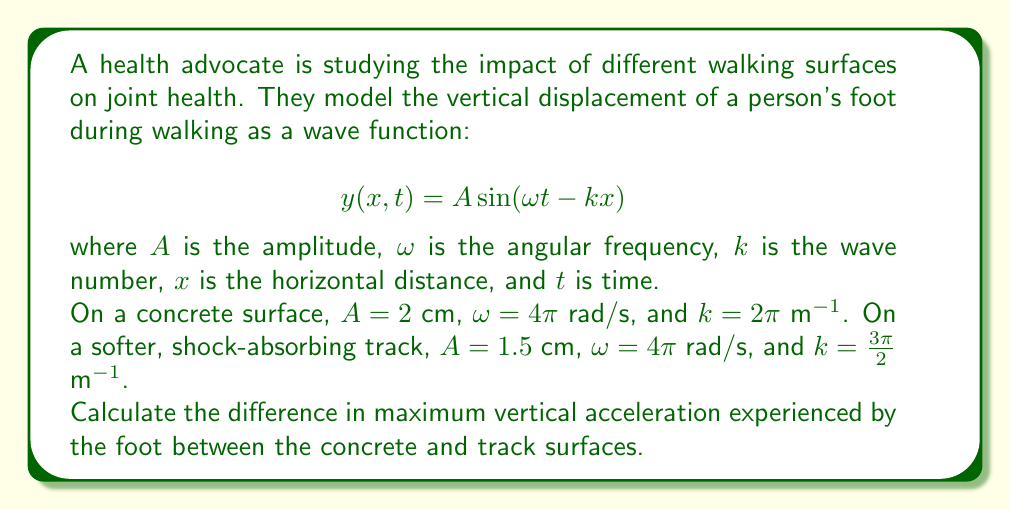Solve this math problem. To solve this problem, we need to follow these steps:

1) The vertical acceleration is given by the second time derivative of the displacement function:

   $$a(x,t) = \frac{\partial^2y}{\partial t^2} = -A\omega^2 \sin(\omega t - kx)$$

2) The maximum acceleration occurs when $\sin(\omega t - kx) = \pm 1$, so:

   $$a_{max} = A\omega^2$$

3) For the concrete surface:
   $A_1 = 2$ cm = 0.02 m
   $\omega_1 = 4\pi$ rad/s

   $$a_{max1} = 0.02 \cdot (4\pi)^2 = 3.16 \text{ m/s}^2$$

4) For the track surface:
   $A_2 = 1.5$ cm = 0.015 m
   $\omega_2 = 4\pi$ rad/s

   $$a_{max2} = 0.015 \cdot (4\pi)^2 = 2.37 \text{ m/s}^2$$

5) The difference in maximum acceleration:

   $$\Delta a_{max} = a_{max1} - a_{max2} = 3.16 - 2.37 = 0.79 \text{ m/s}^2$$

Therefore, the difference in maximum vertical acceleration between the concrete and track surfaces is 0.79 m/s².
Answer: 0.79 m/s² 